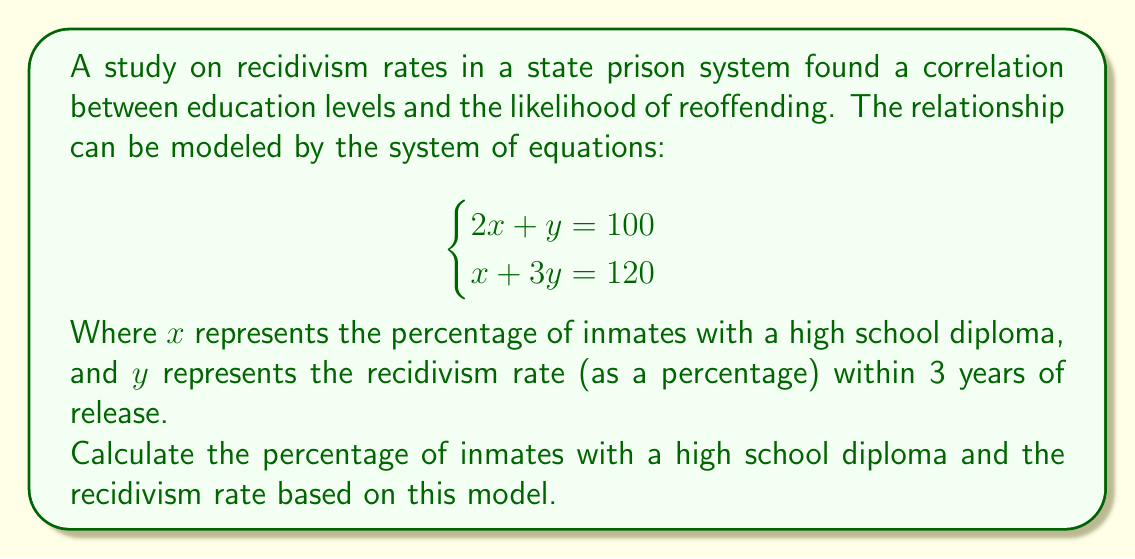Can you answer this question? To solve this system of equations, we can use the substitution method:

1) From the first equation, express $y$ in terms of $x$:
   $$2x + y = 100$$
   $$y = 100 - 2x$$

2) Substitute this expression for $y$ into the second equation:
   $$x + 3(100 - 2x) = 120$$

3) Simplify:
   $$x + 300 - 6x = 120$$
   $$-5x + 300 = 120$$
   $$-5x = -180$$

4) Solve for $x$:
   $$x = 36$$

5) Now that we know $x$, we can find $y$ using either of the original equations. Let's use the first one:
   $$2(36) + y = 100$$
   $$72 + y = 100$$
   $$y = 28$$

Therefore, the percentage of inmates with a high school diploma ($x$) is 36%, and the recidivism rate ($y$) is 28%.

This model suggests that in a prison population where 36% of inmates have a high school diploma, about 28% of released inmates are likely to reoffend within 3 years.
Answer: $x = 36\%$, $y = 28\%$ 